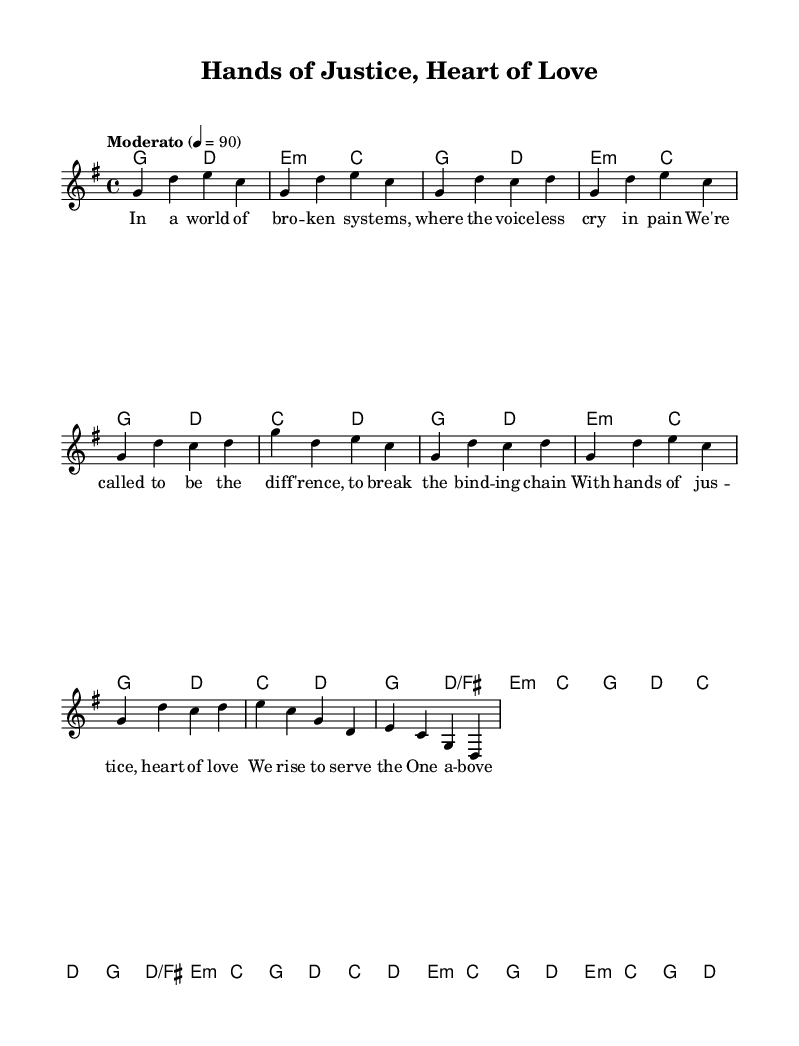What is the key signature of this music? The key signature is G major, indicated by one sharp (F#) in the key signature section at the beginning of the score.
Answer: G major What is the time signature of the piece? The time signature is 4/4, which is stated at the beginning of the score and indicates that there are four beats in each measure.
Answer: 4/4 What is the tempo marking for the song? The tempo marking is "Moderato" at a speed of 90 beats per minute, which is specified at the beginning of the score.
Answer: Moderato 90 How many verses are there in the song structure? The song contains one verse, as indicated in the music section labeled "Verse 1" in the score.
Answer: One What is the primary theme expressed in the chorus? The chorus emphasizes justice and love, reflecting themes of compassion and service to God. This is derived from the lyrics specifically focusing on justice and compassion.
Answer: Justice and love What chord follows the E minor in the verse? The chord progression after E minor in the verse is C major, as shown in the chord names section corresponding to the melody.
Answer: C major Which section of the music emphasizes the theme of justice? The bridge emphasizes the theme of justice with the lyrics "Let justice roll like rivers," which directly refers to the concept of justice.
Answer: Bridge 